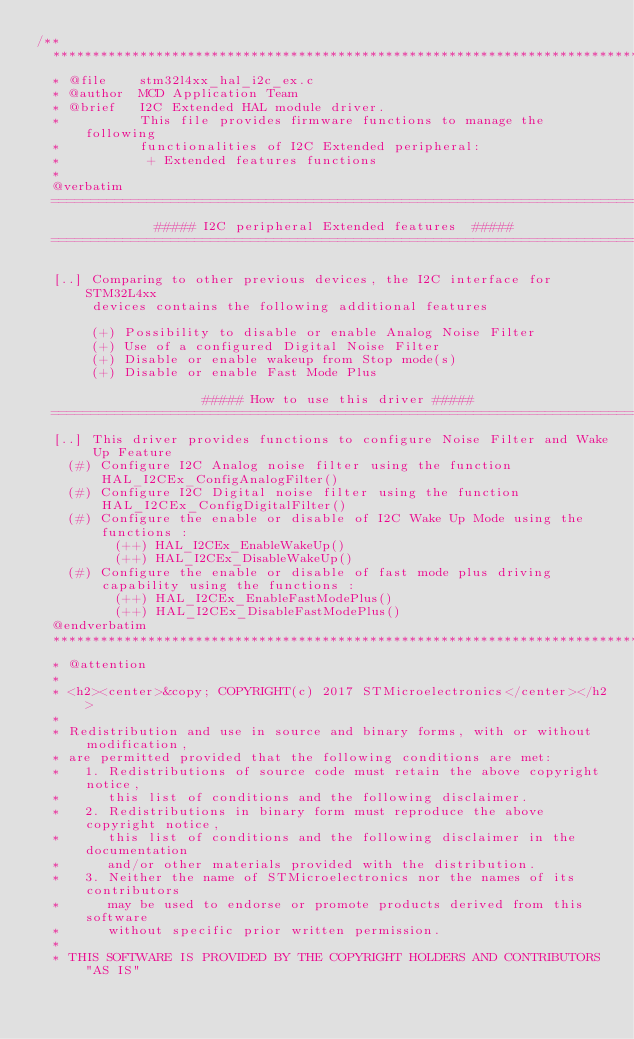<code> <loc_0><loc_0><loc_500><loc_500><_C_>/**
  ******************************************************************************
  * @file    stm32l4xx_hal_i2c_ex.c
  * @author  MCD Application Team
  * @brief   I2C Extended HAL module driver.
  *          This file provides firmware functions to manage the following
  *          functionalities of I2C Extended peripheral:
  *           + Extended features functions
  *
  @verbatim
  ==============================================================================
               ##### I2C peripheral Extended features  #####
  ==============================================================================

  [..] Comparing to other previous devices, the I2C interface for STM32L4xx
       devices contains the following additional features

       (+) Possibility to disable or enable Analog Noise Filter
       (+) Use of a configured Digital Noise Filter
       (+) Disable or enable wakeup from Stop mode(s)
       (+) Disable or enable Fast Mode Plus

                     ##### How to use this driver #####
  ==============================================================================
  [..] This driver provides functions to configure Noise Filter and Wake Up Feature
    (#) Configure I2C Analog noise filter using the function HAL_I2CEx_ConfigAnalogFilter()
    (#) Configure I2C Digital noise filter using the function HAL_I2CEx_ConfigDigitalFilter()
    (#) Configure the enable or disable of I2C Wake Up Mode using the functions :
          (++) HAL_I2CEx_EnableWakeUp()
          (++) HAL_I2CEx_DisableWakeUp()
    (#) Configure the enable or disable of fast mode plus driving capability using the functions :
          (++) HAL_I2CEx_EnableFastModePlus()
          (++) HAL_I2CEx_DisableFastModePlus()
  @endverbatim
  ******************************************************************************
  * @attention
  *
  * <h2><center>&copy; COPYRIGHT(c) 2017 STMicroelectronics</center></h2>
  *
  * Redistribution and use in source and binary forms, with or without modification,
  * are permitted provided that the following conditions are met:
  *   1. Redistributions of source code must retain the above copyright notice,
  *      this list of conditions and the following disclaimer.
  *   2. Redistributions in binary form must reproduce the above copyright notice,
  *      this list of conditions and the following disclaimer in the documentation
  *      and/or other materials provided with the distribution.
  *   3. Neither the name of STMicroelectronics nor the names of its contributors
  *      may be used to endorse or promote products derived from this software
  *      without specific prior written permission.
  *
  * THIS SOFTWARE IS PROVIDED BY THE COPYRIGHT HOLDERS AND CONTRIBUTORS "AS IS"</code> 